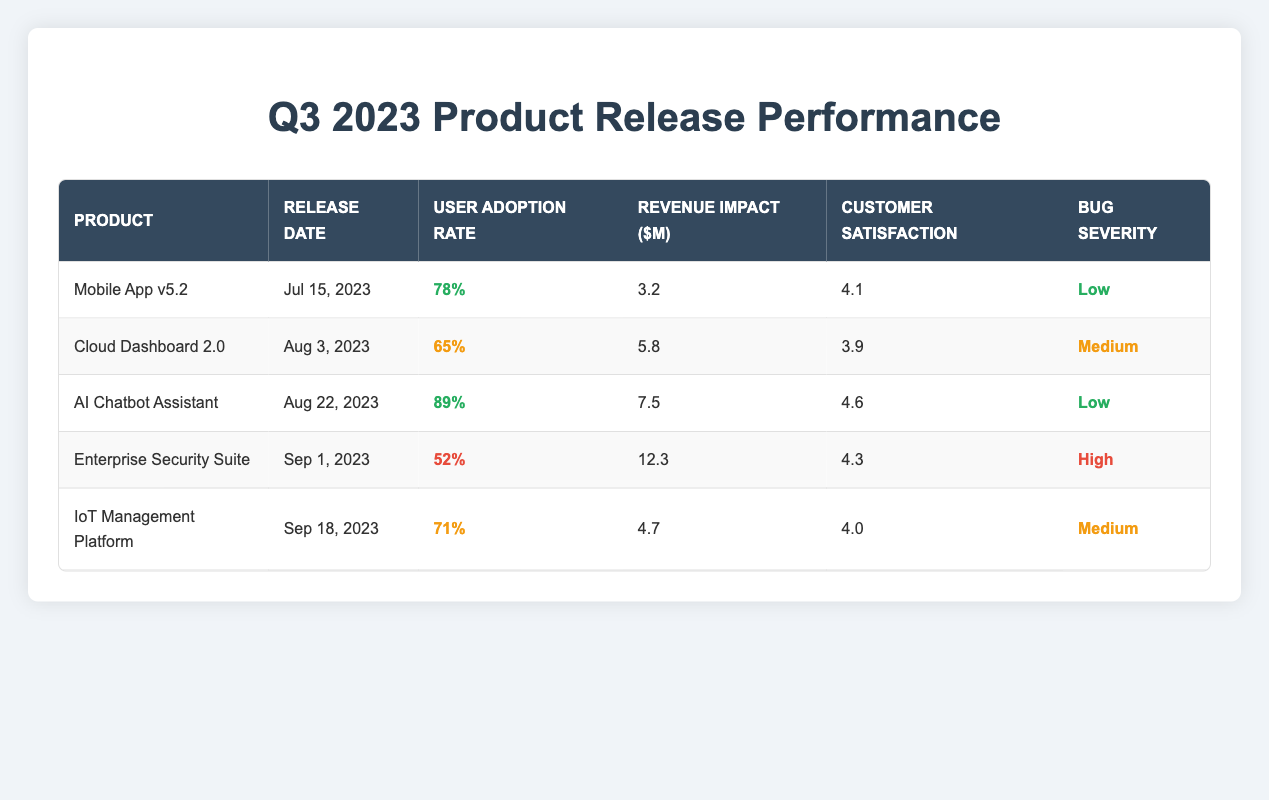What is the user adoption rate of the AI Chatbot Assistant? The user adoption rate is listed in the "User Adoption Rate" column for the AI Chatbot Assistant which is 89%.
Answer: 89% Which product had the highest revenue impact? The "Revenue Impact ($M)" column indicates that the Enterprise Security Suite had the highest revenue impact at 12.3 million dollars.
Answer: 12.3 million dollars Is the customer satisfaction for the Mobile App v5.2 above 4.0? The customer satisfaction rating for the Mobile App v5.2 is 4.1, which is above 4.0.
Answer: Yes What is the average user adoption rate for all products released? To compute the average user adoption rate, we convert the percentages to decimals: (0.78 + 0.65 + 0.89 + 0.52 + 0.71) = 3.55. Dividing by 5 gives an average of 0.71 which is 71%.
Answer: 71% Which products have low bug severity? The products with low bug severity are the Mobile App v5.2 and the AI Chatbot Assistant, as indicated in the "Bug Severity" column which shows "Low" for both products.
Answer: Mobile App v5.2 and AI Chatbot Assistant What percentage of products had a user adoption rate below 70%? The products with a user adoption rate below 70% are Cloud Dashboard 2.0 (65%) and Enterprise Security Suite (52%). Thus, out of 5 total products, 2 have low adoption, so (2/5)*100 = 40% of the products had a user adoption rate below 70%.
Answer: 40% Was the revenue impact of the IoT Management Platform higher than the Cloud Dashboard 2.0? Comparing the revenue impacts, IoT Management Platform (4.7 million dollars) is less than Cloud Dashboard 2.0, which had a revenue impact of 5.8 million dollars.
Answer: No How many products had a customer satisfaction rating of 4.5 or higher? Checking the "Customer Satisfaction" column, the products that meet this criterion are Mobile App v5.2 (4.1), AI Chatbot Assistant (4.6), and Enterprise Security Suite (4.3). Thus, 2 out of 5 products had ratings of 4.5 or higher.
Answer: 2 What is the total revenue impact of all products released? To find the total revenue impact, sum the individual revenue impacts: 3.2 + 5.8 + 7.5 + 12.3 + 4.7 = 33.5 million dollars.
Answer: 33.5 million dollars Which product was released last and what was its user adoption rate? The last product released was the IoT Management Platform on September 18, 2023, which had a user adoption rate of 71%.
Answer: IoT Management Platform, 71% 